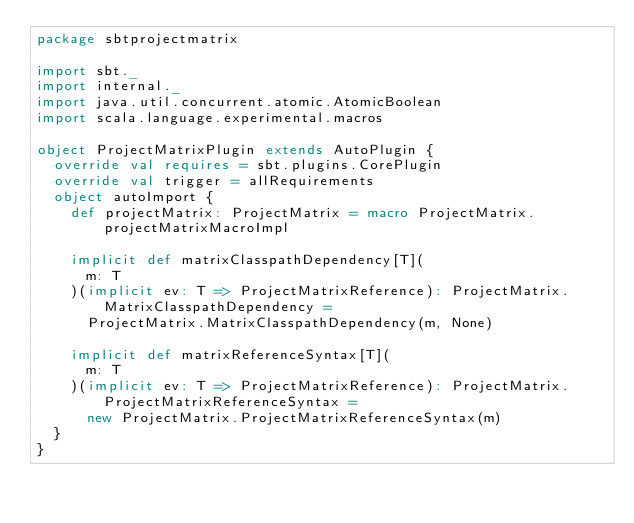Convert code to text. <code><loc_0><loc_0><loc_500><loc_500><_Scala_>package sbtprojectmatrix

import sbt._
import internal._
import java.util.concurrent.atomic.AtomicBoolean
import scala.language.experimental.macros

object ProjectMatrixPlugin extends AutoPlugin {
  override val requires = sbt.plugins.CorePlugin
  override val trigger = allRequirements
  object autoImport {
    def projectMatrix: ProjectMatrix = macro ProjectMatrix.projectMatrixMacroImpl

    implicit def matrixClasspathDependency[T](
      m: T
    )(implicit ev: T => ProjectMatrixReference): ProjectMatrix.MatrixClasspathDependency =
      ProjectMatrix.MatrixClasspathDependency(m, None)

    implicit def matrixReferenceSyntax[T](
      m: T
    )(implicit ev: T => ProjectMatrixReference): ProjectMatrix.ProjectMatrixReferenceSyntax =
      new ProjectMatrix.ProjectMatrixReferenceSyntax(m)
  }
}
</code> 